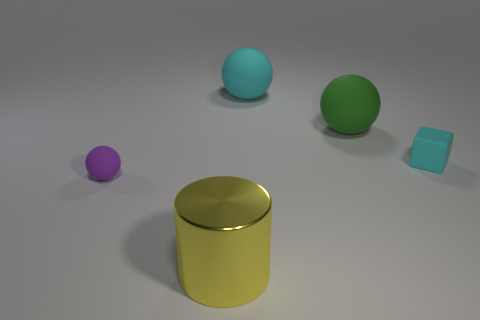Subtract all large balls. How many balls are left? 1 Subtract all purple spheres. How many spheres are left? 2 Add 5 cyan cubes. How many objects exist? 10 Subtract 0 purple cubes. How many objects are left? 5 Subtract all cylinders. How many objects are left? 4 Subtract 1 cylinders. How many cylinders are left? 0 Subtract all purple balls. Subtract all yellow cylinders. How many balls are left? 2 Subtract all purple cylinders. How many red spheres are left? 0 Subtract all metal blocks. Subtract all large cyan matte balls. How many objects are left? 4 Add 1 large green rubber objects. How many large green rubber objects are left? 2 